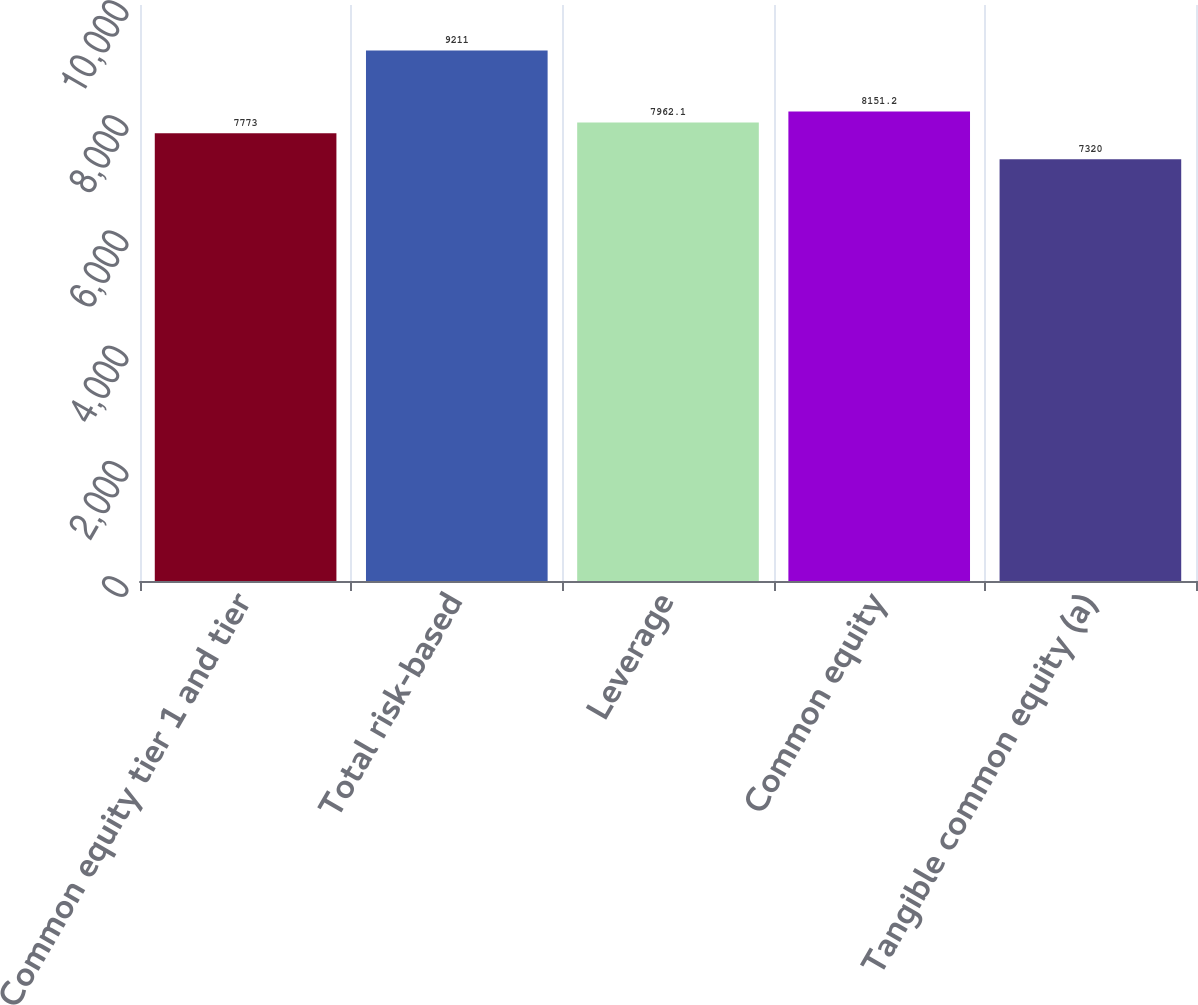Convert chart. <chart><loc_0><loc_0><loc_500><loc_500><bar_chart><fcel>Common equity tier 1 and tier<fcel>Total risk-based<fcel>Leverage<fcel>Common equity<fcel>Tangible common equity (a)<nl><fcel>7773<fcel>9211<fcel>7962.1<fcel>8151.2<fcel>7320<nl></chart> 